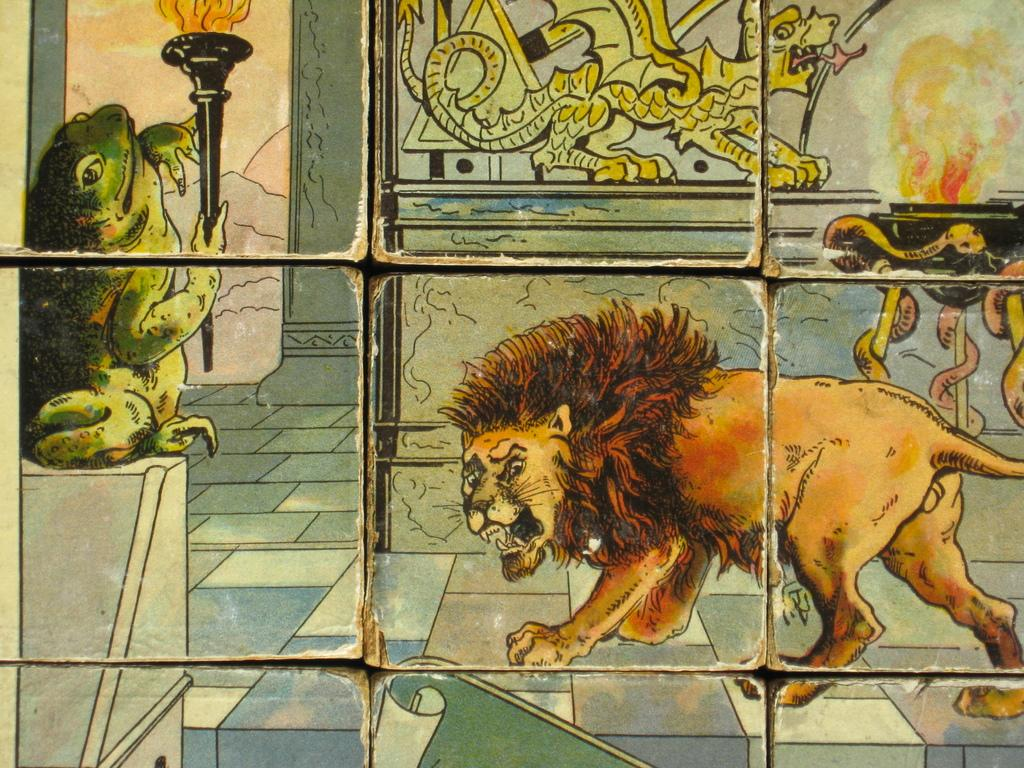What type of artwork is depicted in the image? The image is a painting. What animal can be seen on the right side of the painting? There is a lion on the right side of the painting. What creatures are also present on the right side of the painting? There are snakes on the right side of the painting. What amphibian is located on the left side of the painting? There is a frog on the left side of the painting. What element is present on the left side of the painting? There is fire on the left side of the painting. What can be seen in the background of the painting? There is a wall in the background of the painting. What type of reaction can be seen from the needle in the painting? There is no needle present in the painting; it features a lion, snakes, a frog, fire, and a wall. 